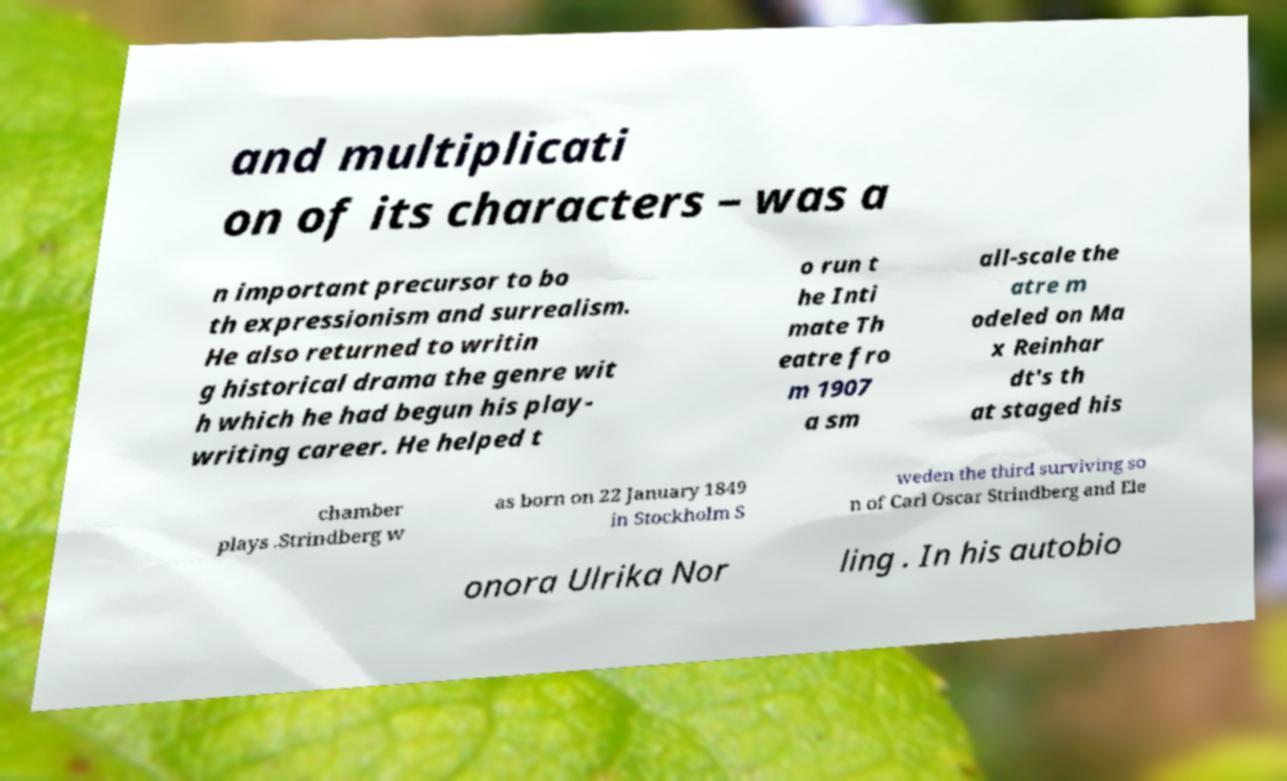Could you extract and type out the text from this image? and multiplicati on of its characters – was a n important precursor to bo th expressionism and surrealism. He also returned to writin g historical drama the genre wit h which he had begun his play- writing career. He helped t o run t he Inti mate Th eatre fro m 1907 a sm all-scale the atre m odeled on Ma x Reinhar dt's th at staged his chamber plays .Strindberg w as born on 22 January 1849 in Stockholm S weden the third surviving so n of Carl Oscar Strindberg and Ele onora Ulrika Nor ling . In his autobio 